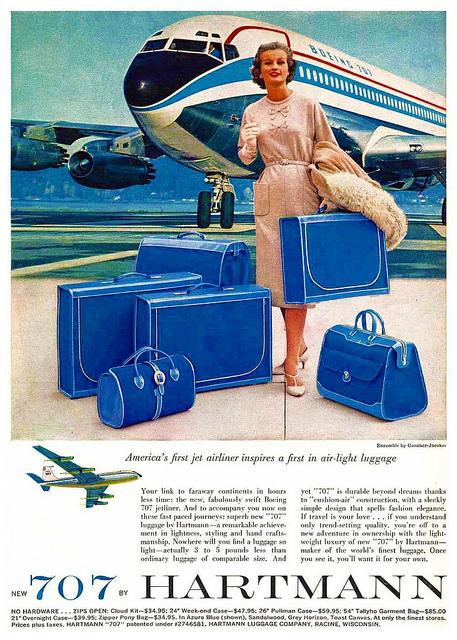Is this an advertisement?
Write a very short answer. Yes. How many bags are shown?
Write a very short answer. 6. Is this a modern ad?
Concise answer only. No. 